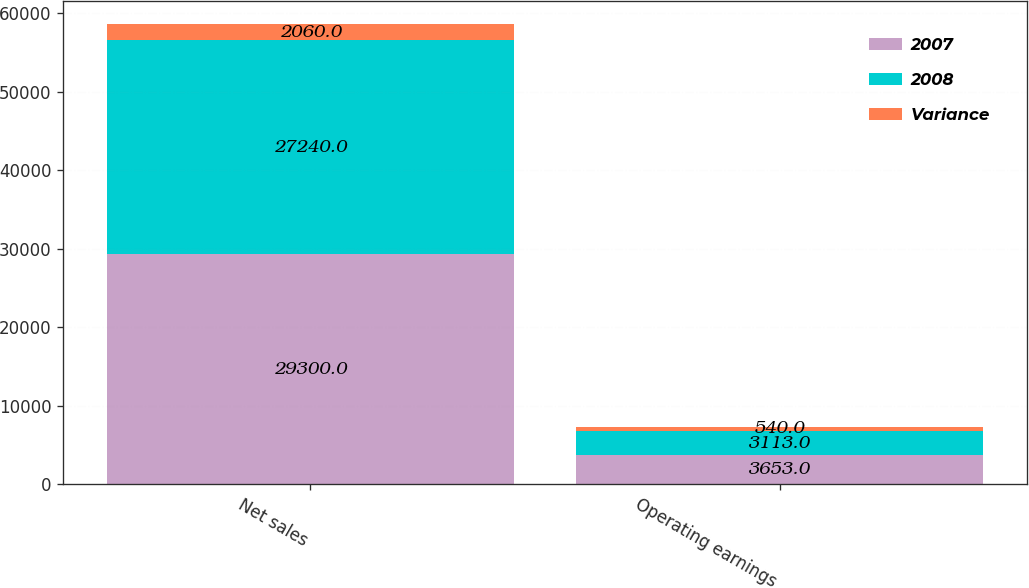Convert chart. <chart><loc_0><loc_0><loc_500><loc_500><stacked_bar_chart><ecel><fcel>Net sales<fcel>Operating earnings<nl><fcel>2007<fcel>29300<fcel>3653<nl><fcel>2008<fcel>27240<fcel>3113<nl><fcel>Variance<fcel>2060<fcel>540<nl></chart> 